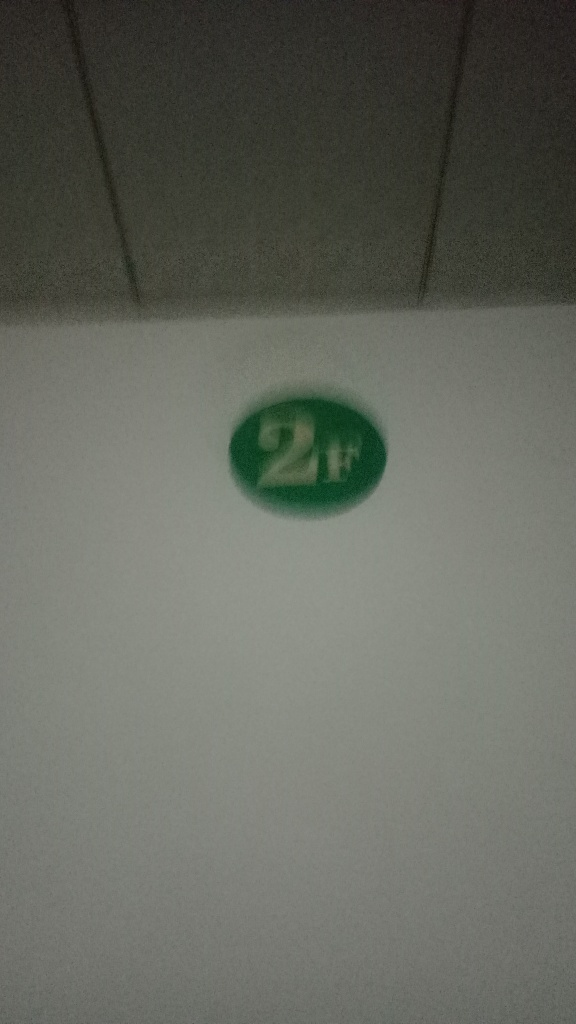What might the '2H' symbol indicate in this context? The '2H' marking usually signifies a hardness grade of a pencil, indicating it is relatively hard and yields a lighter mark compared to softer pencils. In this image, it might represent something similar or be a label or identifier for a specific object or place. 